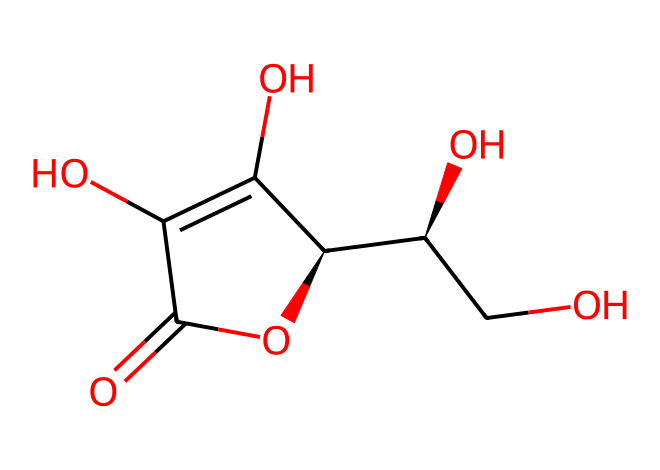How many carbon atoms are in the structure? By examining the SMILES representation, we can count the number of carbon (C) atoms present. The structure indicates there are five distinct carbon atoms.
Answer: five What is the molecular formula of this compound? Analyzing the SMILES representation, each atom needs to be counted: there are six carbons, six hydrogens, and eight oxygens, leading to the molecular formula C6H8O6.
Answer: C6H8O6 Is this compound a monosaccharide, disaccharide, or another type of sugar? The presence of a cyclic structure and multiple hydroxyl groups indicates that this molecule is classified as a sugar, specifically an ascorbic acid (vitamin C), which is not a typical monosaccharide but has sugar-like properties.
Answer: vitamin What role does this molecule play as an antioxidant? Analyzing the chemical structure, vitamin C donates electrons due to the hydroxyl (OH) groups, which helps neutralize free radicals, thereby preventing oxidative stress.
Answer: neutralizes free radicals How many hydroxyl (-OH) groups are present in the structure? By inspecting the structure derived from the SMILES notation, there are four distinct hydroxyl groups present throughout the molecule.
Answer: four What functional groups can be identified in this antioxidant? Reviewing the structure shows the presence of hydroxyl groups (-OH) and a lactone ring, making them key functional groups that impart antioxidant properties.
Answer: hydroxyl and lactone What type of bonding is primarily found in this antioxidant structure? The structure includes covalent bonds between carbon, oxygen, and hydrogen atoms, as indicated by how these atoms are connected within the SMILES notation.
Answer: covalent bonds 